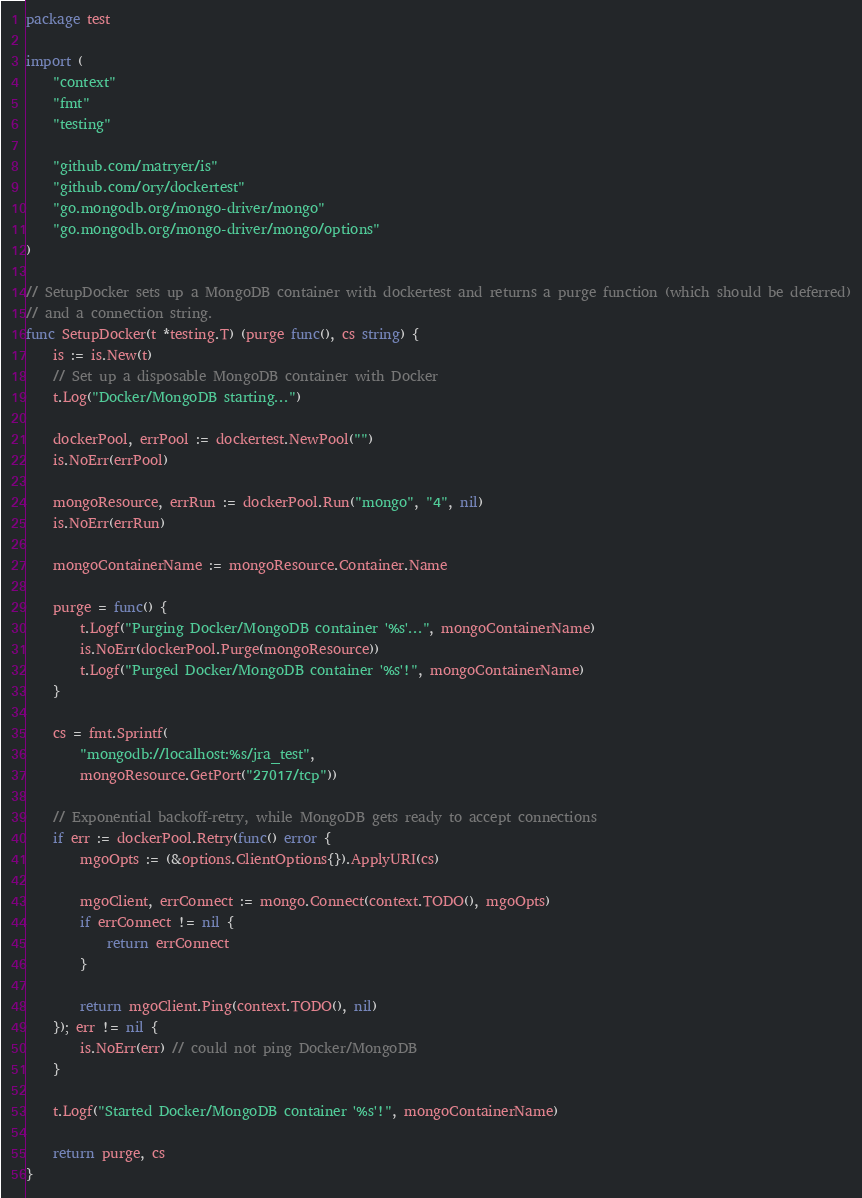Convert code to text. <code><loc_0><loc_0><loc_500><loc_500><_Go_>package test

import (
	"context"
	"fmt"
	"testing"

	"github.com/matryer/is"
	"github.com/ory/dockertest"
	"go.mongodb.org/mongo-driver/mongo"
	"go.mongodb.org/mongo-driver/mongo/options"
)

// SetupDocker sets up a MongoDB container with dockertest and returns a purge function (which should be deferred)
// and a connection string.
func SetupDocker(t *testing.T) (purge func(), cs string) {
	is := is.New(t)
	// Set up a disposable MongoDB container with Docker
	t.Log("Docker/MongoDB starting...")

	dockerPool, errPool := dockertest.NewPool("")
	is.NoErr(errPool)

	mongoResource, errRun := dockerPool.Run("mongo", "4", nil)
	is.NoErr(errRun)

	mongoContainerName := mongoResource.Container.Name

	purge = func() {
		t.Logf("Purging Docker/MongoDB container '%s'...", mongoContainerName)
		is.NoErr(dockerPool.Purge(mongoResource))
		t.Logf("Purged Docker/MongoDB container '%s'!", mongoContainerName)
	}

	cs = fmt.Sprintf(
		"mongodb://localhost:%s/jra_test",
		mongoResource.GetPort("27017/tcp"))

	// Exponential backoff-retry, while MongoDB gets ready to accept connections
	if err := dockerPool.Retry(func() error {
		mgoOpts := (&options.ClientOptions{}).ApplyURI(cs)

		mgoClient, errConnect := mongo.Connect(context.TODO(), mgoOpts)
		if errConnect != nil {
			return errConnect
		}

		return mgoClient.Ping(context.TODO(), nil)
	}); err != nil {
		is.NoErr(err) // could not ping Docker/MongoDB
	}

	t.Logf("Started Docker/MongoDB container '%s'!", mongoContainerName)

	return purge, cs
}
</code> 